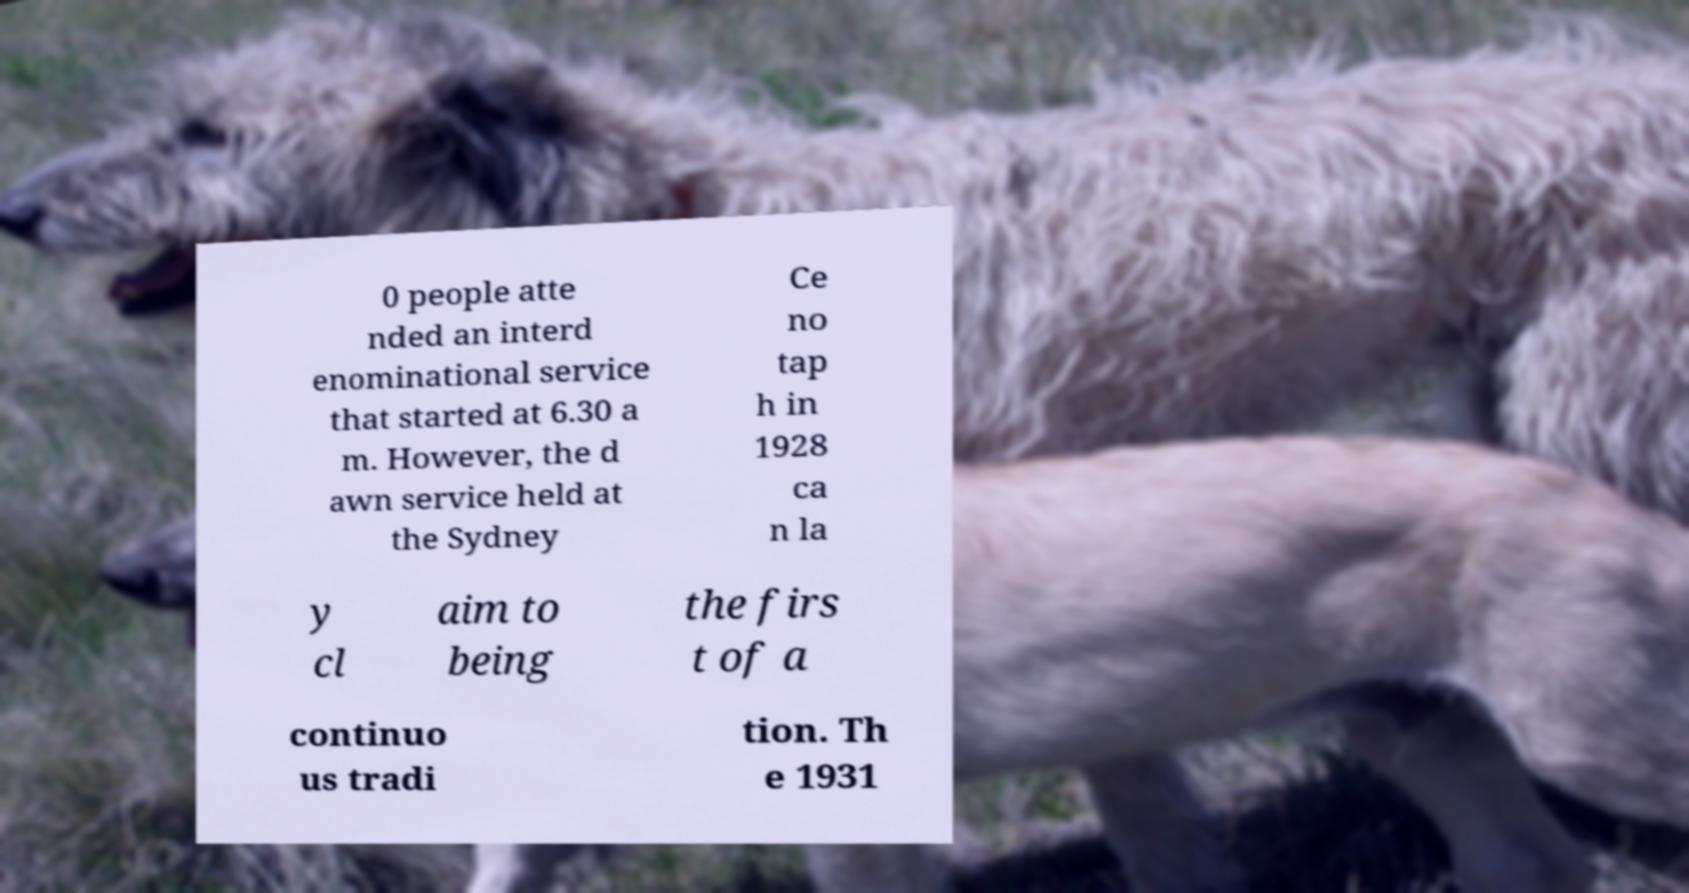For documentation purposes, I need the text within this image transcribed. Could you provide that? 0 people atte nded an interd enominational service that started at 6.30 a m. However, the d awn service held at the Sydney Ce no tap h in 1928 ca n la y cl aim to being the firs t of a continuo us tradi tion. Th e 1931 